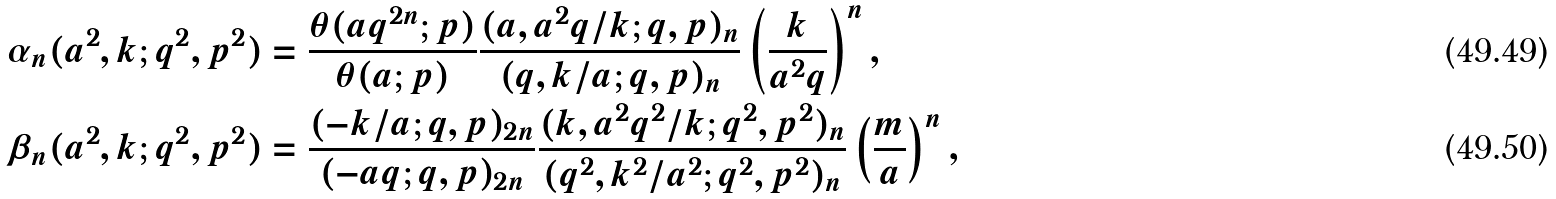<formula> <loc_0><loc_0><loc_500><loc_500>\alpha _ { n } ( a ^ { 2 } , k ; q ^ { 2 } , p ^ { 2 } ) & = \frac { \theta ( a q ^ { 2 n } ; p ) } { \theta ( a ; p ) } \frac { ( a , a ^ { 2 } q / k ; q , p ) _ { n } } { ( q , k / a ; q , p ) _ { n } } \left ( \frac { k } { a ^ { 2 } q } \right ) ^ { n } , \\ \beta _ { n } ( a ^ { 2 } , k ; q ^ { 2 } , p ^ { 2 } ) & = \frac { ( - k / a ; q , p ) _ { 2 n } } { ( - a q ; q , p ) _ { 2 n } } \frac { ( k , a ^ { 2 } q ^ { 2 } / k ; q ^ { 2 } , p ^ { 2 } ) _ { n } } { ( q ^ { 2 } , k ^ { 2 } / a ^ { 2 } ; q ^ { 2 } , p ^ { 2 } ) _ { n } } \left ( \frac { m } { a } \right ) ^ { n } ,</formula> 